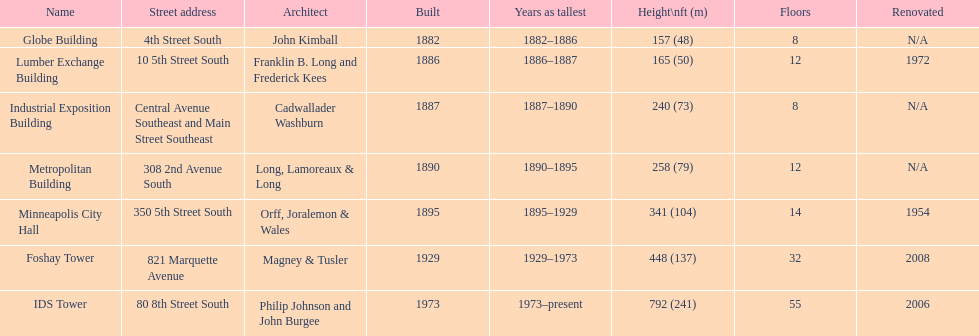Parse the table in full. {'header': ['Name', 'Street address', 'Architect', 'Built', 'Years as tallest', 'Height\\nft (m)', 'Floors', 'Renovated'], 'rows': [['Globe Building', '4th Street South', 'John Kimball', '1882', '1882–1886', '157 (48)', '8', 'N/A'], ['Lumber Exchange Building', '10 5th Street South', 'Franklin B. Long and Frederick Kees', '1886', '1886–1887', '165 (50)', '12', '1972'], ['Industrial Exposition Building', 'Central Avenue Southeast and Main Street Southeast', 'Cadwallader Washburn', '1887', '1887–1890', '240 (73)', '8', 'N/A'], ['Metropolitan Building', '308 2nd Avenue South', 'Long, Lamoreaux & Long', '1890', '1890–1895', '258 (79)', '12', 'N/A'], ['Minneapolis City Hall', '350 5th Street South', 'Orff, Joralemon & Wales', '1895', '1895–1929', '341 (104)', '14', '1954'], ['Foshay Tower', '821 Marquette Avenue', 'Magney & Tusler', '1929', '1929–1973', '448 (137)', '32', '2008'], ['IDS Tower', '80 8th Street South', 'Philip Johnson and John Burgee', '1973', '1973–present', '792 (241)', '55', '2006']]} How tall is it to the top of the ids tower in feet? 792. 